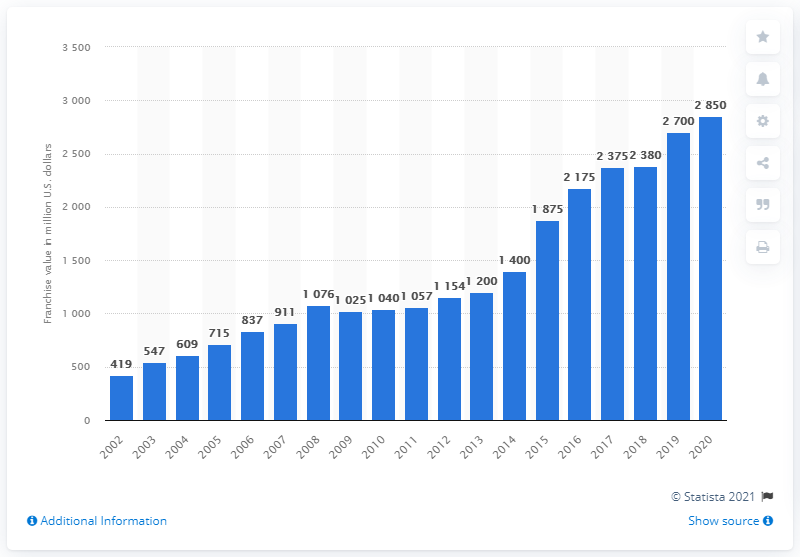Draw attention to some important aspects in this diagram. The value of the Indianapolis Colts in dollars in 2020 was approximately $28.5 billion. 